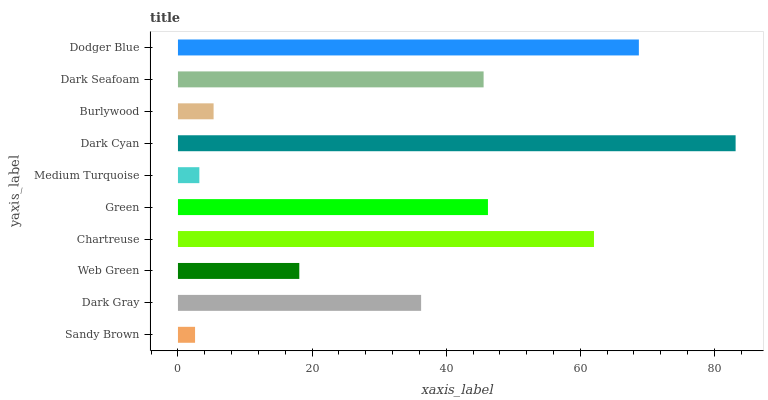Is Sandy Brown the minimum?
Answer yes or no. Yes. Is Dark Cyan the maximum?
Answer yes or no. Yes. Is Dark Gray the minimum?
Answer yes or no. No. Is Dark Gray the maximum?
Answer yes or no. No. Is Dark Gray greater than Sandy Brown?
Answer yes or no. Yes. Is Sandy Brown less than Dark Gray?
Answer yes or no. Yes. Is Sandy Brown greater than Dark Gray?
Answer yes or no. No. Is Dark Gray less than Sandy Brown?
Answer yes or no. No. Is Dark Seafoam the high median?
Answer yes or no. Yes. Is Dark Gray the low median?
Answer yes or no. Yes. Is Chartreuse the high median?
Answer yes or no. No. Is Green the low median?
Answer yes or no. No. 